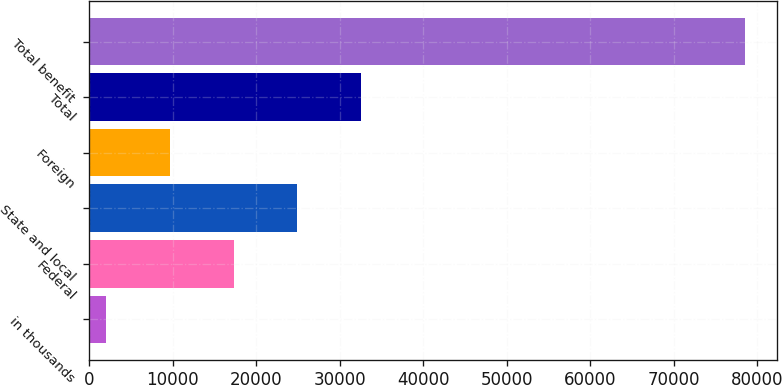<chart> <loc_0><loc_0><loc_500><loc_500><bar_chart><fcel>in thousands<fcel>Federal<fcel>State and local<fcel>Foreign<fcel>Total<fcel>Total benefit<nl><fcel>2011<fcel>17305.4<fcel>24952.6<fcel>9658.2<fcel>32599.8<fcel>78483<nl></chart> 